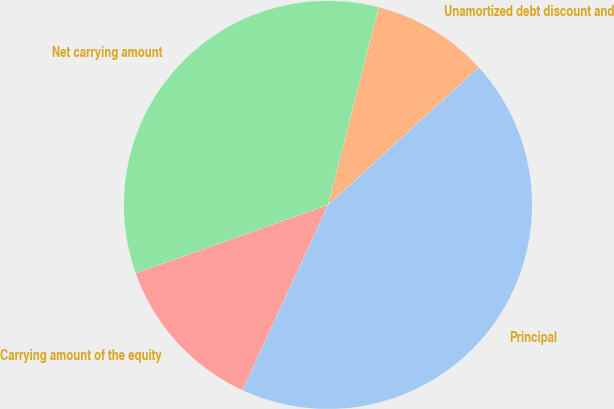Convert chart to OTSL. <chart><loc_0><loc_0><loc_500><loc_500><pie_chart><fcel>Principal<fcel>Unamortized debt discount and<fcel>Net carrying amount<fcel>Carrying amount of the equity<nl><fcel>43.67%<fcel>9.22%<fcel>34.45%<fcel>12.67%<nl></chart> 